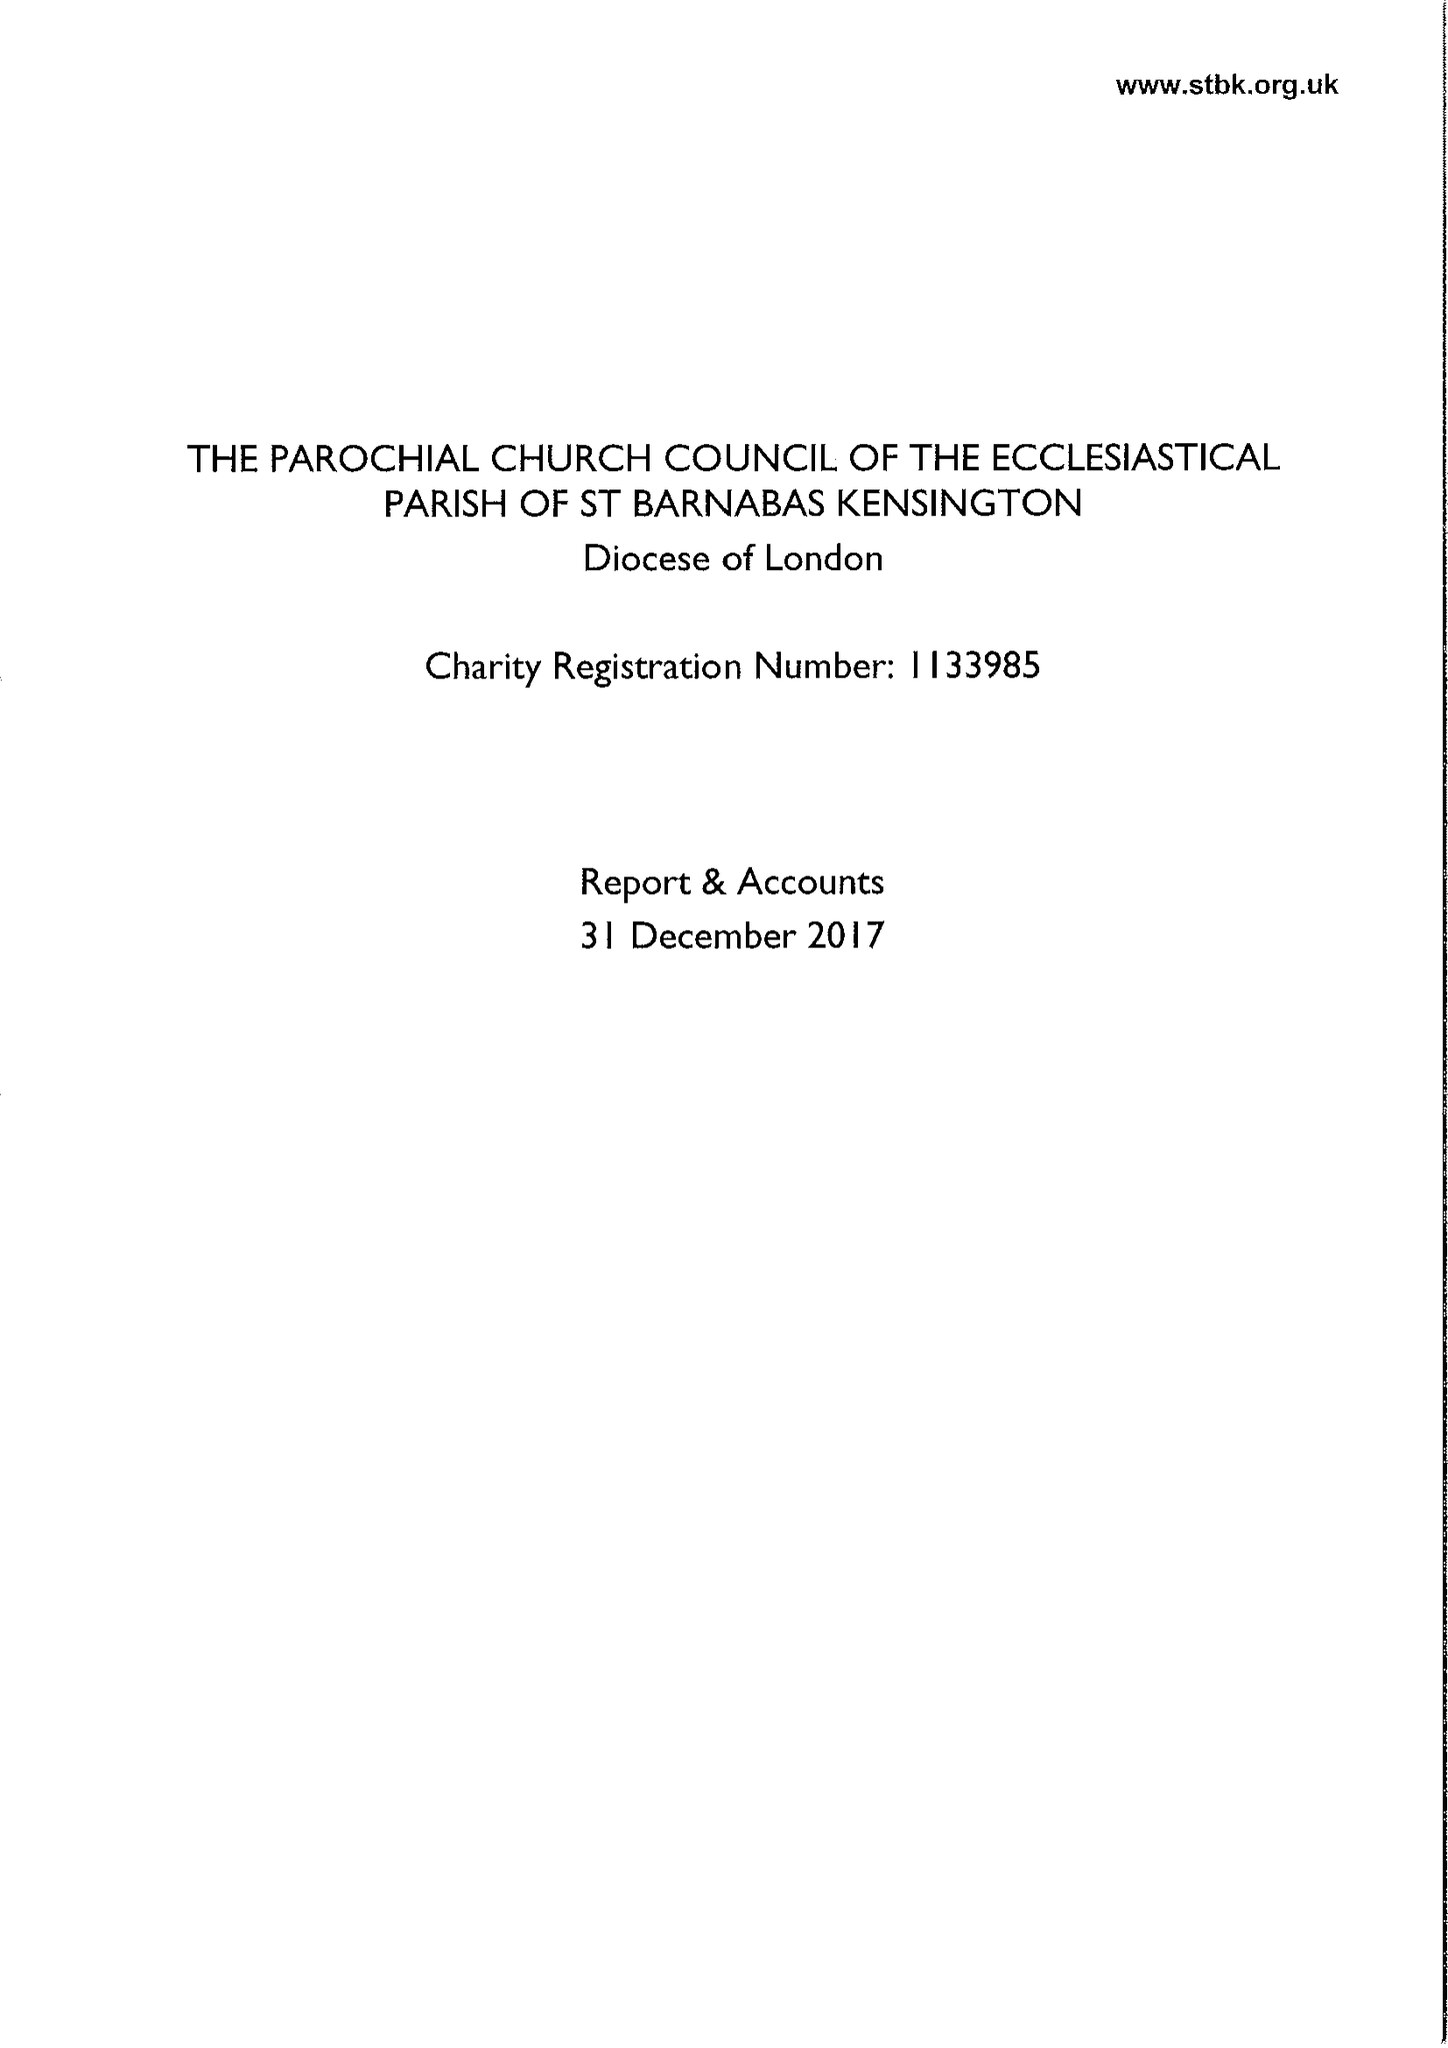What is the value for the income_annually_in_british_pounds?
Answer the question using a single word or phrase. 495612.00 